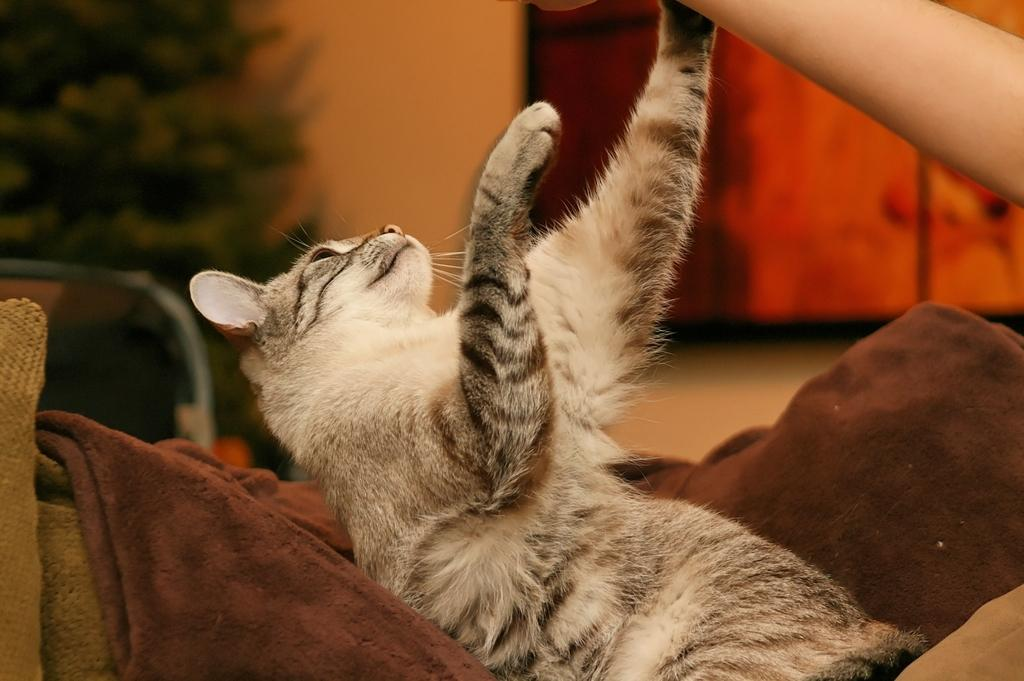What type of animal can be seen in the image? There is a cat in the image. What part of a human is visible in the image? A human hand is visible in the image. What is the cat sitting on in the image? There is a blanket in the image. What type of plant is on the side of the image? There is a tree on the side of the image. What might the cat be using for comfort in the image? A cushion is present in the image. What type of brake can be seen on the tree in the image? There is no brake present in the image, as it features a cat, human hand, blanket, tree, and cushion. 